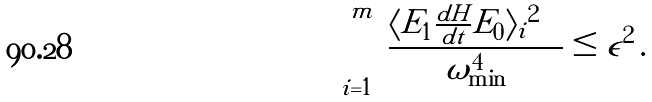<formula> <loc_0><loc_0><loc_500><loc_500>\sum _ { i = 1 } ^ { m } \frac { | \langle E _ { 1 } | \frac { d H } { d t } | E _ { 0 } \rangle _ { i } | ^ { 2 } } { \omega _ { \min } ^ { 4 } } \leq \epsilon ^ { 2 } \, .</formula> 